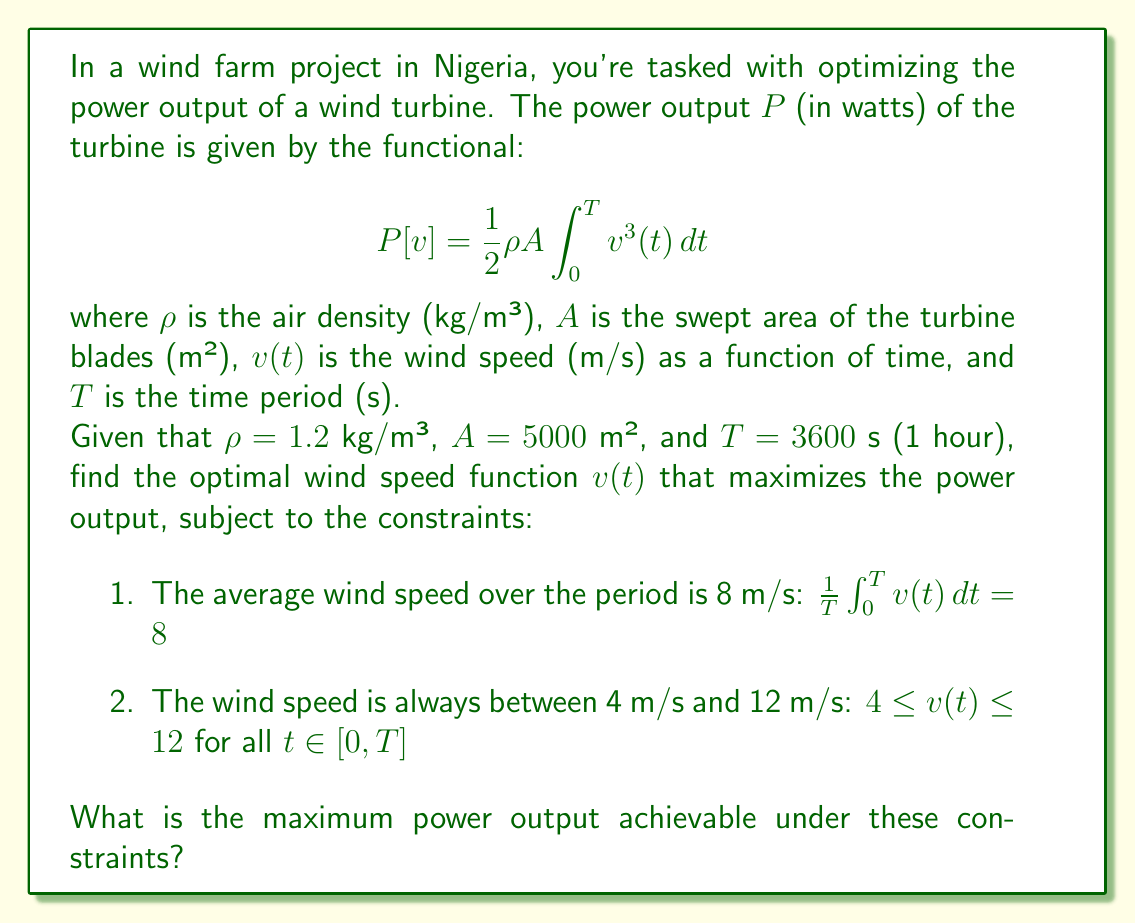Solve this math problem. To solve this optimization problem, we'll use the calculus of variations and the method of Lagrange multipliers.

1) First, we form the augmented functional with a Lagrange multiplier $\lambda$:

   $$J[v] = \frac{1}{2}\rho A \int_0^T v^3(t) \, dt - \lambda \left(\frac{1}{T}\int_0^T v(t) \, dt - 8\right)$$

2) The Euler-Lagrange equation for this functional is:

   $$\frac{\partial}{\partial v}\left(\frac{1}{2}\rho A v^3 - \frac{\lambda}{T}v\right) = 0$$

3) Solving this equation:

   $$\frac{3}{2}\rho A v^2 - \frac{\lambda}{T} = 0$$

   $$v^2 = \frac{2\lambda}{3\rho AT}$$

4) This suggests that the optimal $v(t)$ is constant. Let's call this constant $v_0$. From the first constraint:

   $$v_0 = 8 \text{ m/s}$$

5) We need to check if this satisfies the second constraint, which it does (4 ≤ 8 ≤ 12).

6) Now we can calculate the maximum power output:

   $$P_{max} = \frac{1}{2}\rho A \int_0^T v_0^3 \, dt = \frac{1}{2}\rho A v_0^3 T$$

7) Substituting the given values:

   $$P_{max} = \frac{1}{2} \cdot 1.2 \cdot 5000 \cdot 8^3 \cdot 3600 = 3,686,400,000 \text{ watts}$$

Therefore, the maximum power output achievable is 3,686.4 MW.
Answer: The maximum power output achievable is 3,686.4 MW, obtained with a constant wind speed of 8 m/s. 